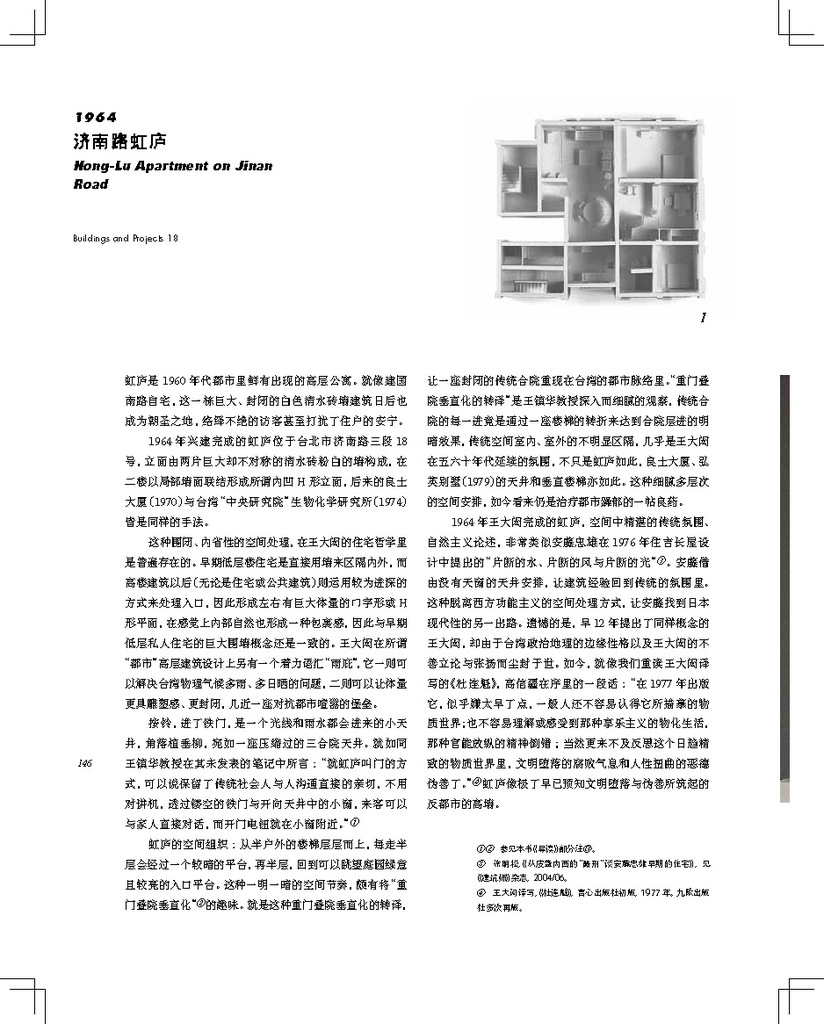How might this floor plan reflect the living standards and cultural values of the time it was designed? The floor plan might reflect an emphasis on community and shared living spaces typical of the era, with a balance between private and public areas within the home, mirroring the social dynamics and domestic priorities of the 1960s. 